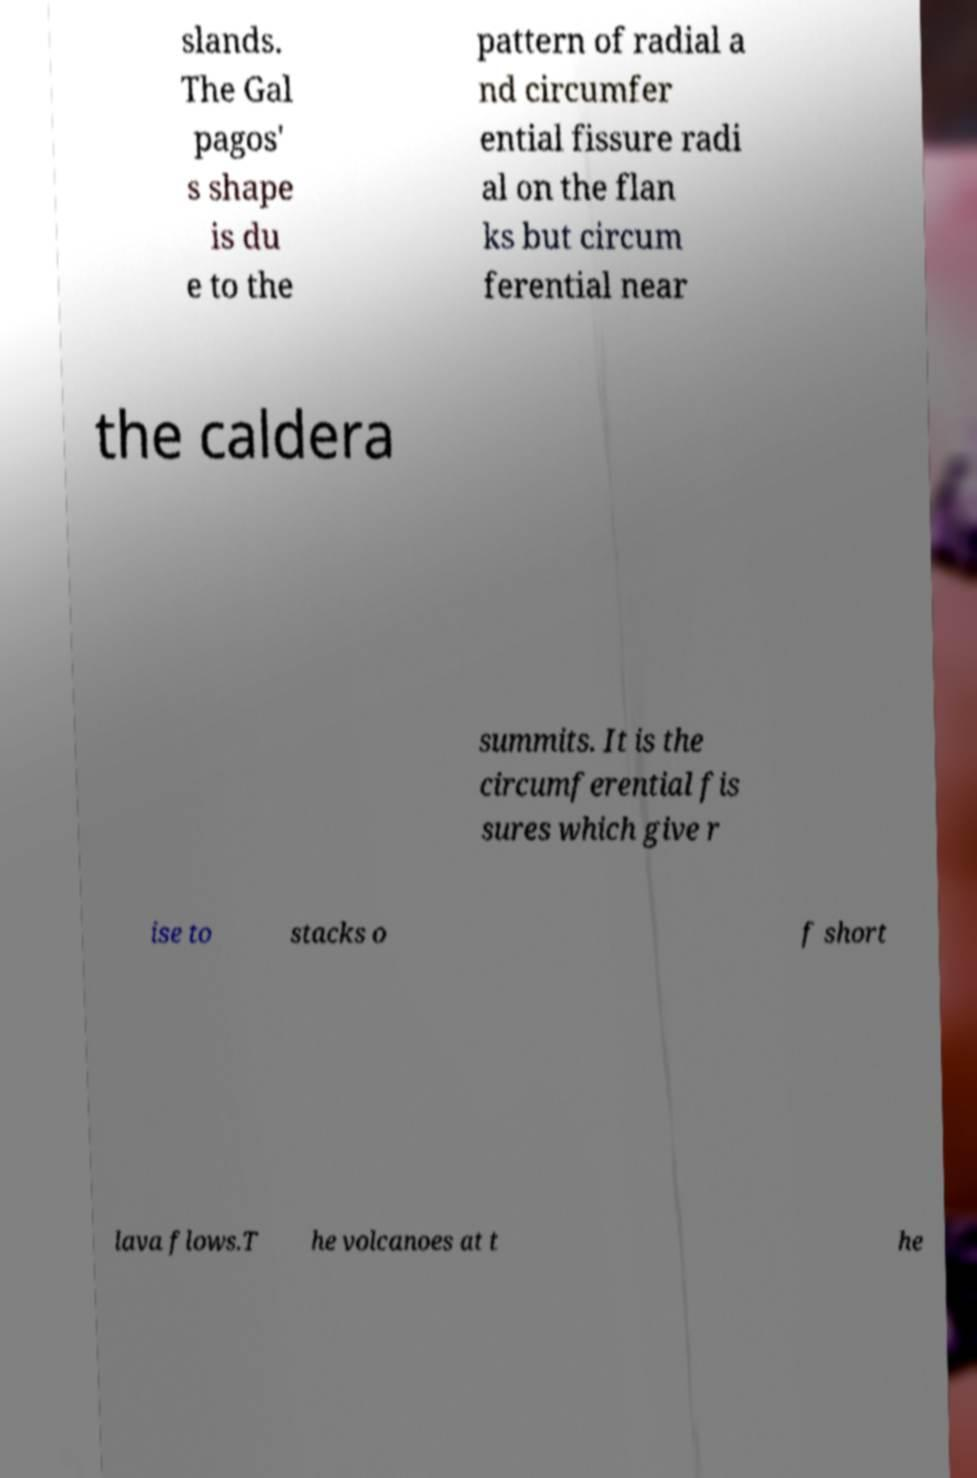What messages or text are displayed in this image? I need them in a readable, typed format. slands. The Gal pagos' s shape is du e to the pattern of radial a nd circumfer ential fissure radi al on the flan ks but circum ferential near the caldera summits. It is the circumferential fis sures which give r ise to stacks o f short lava flows.T he volcanoes at t he 